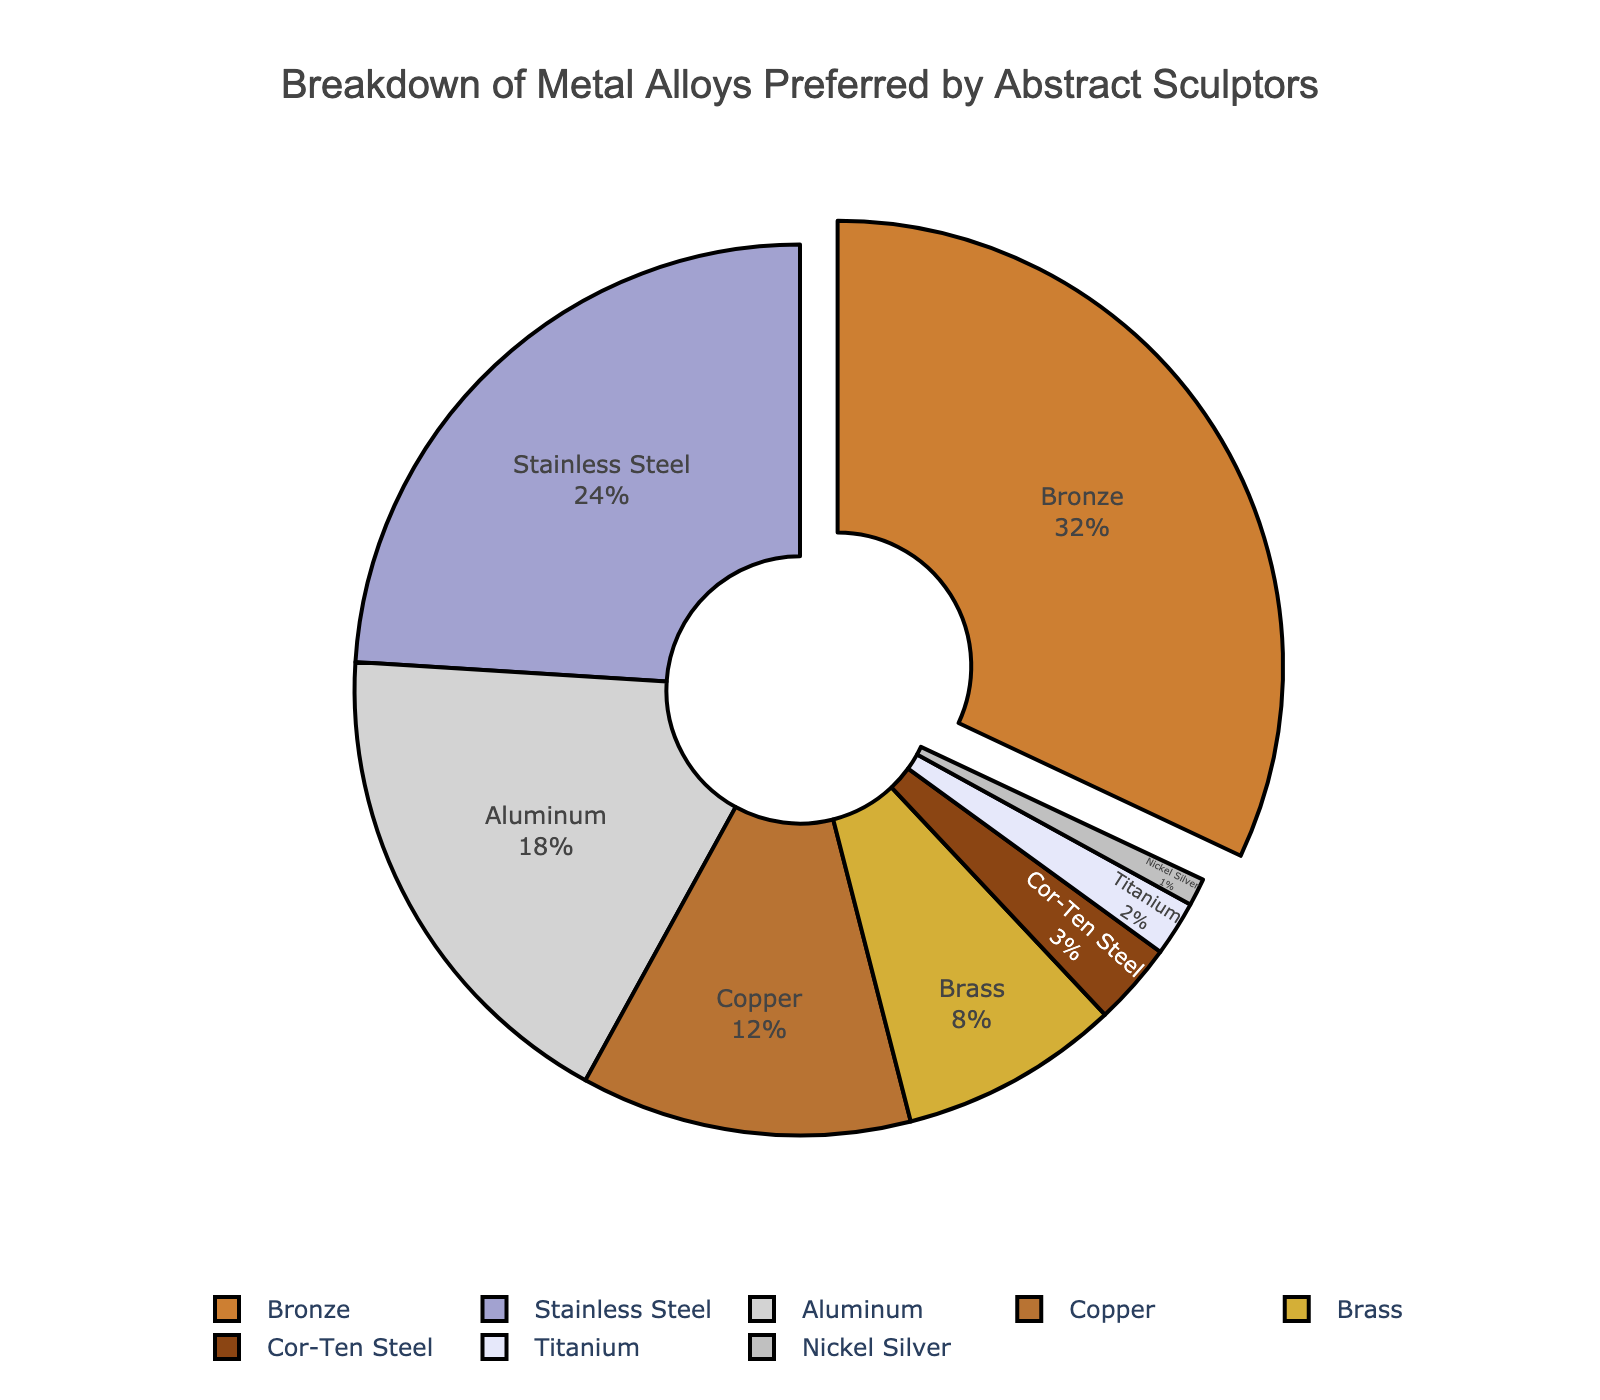What is the most preferred metal alloy by abstract sculptors? The most preferred metal alloy is indicated by the largest slice in the pie chart. The chart highlights this slice by pulling it out slightly. The metal alloy that is pulled out and has the largest slice is Bronze.
Answer: Bronze Which metal alloy has the second-highest preference among abstract sculptors? The second-largest slice in the pie chart will indicate the metal alloy with the second-highest preference. This slice corresponds to Stainless Steel.
Answer: Stainless Steel What is the combined percentage for Aluminum and Copper? To find the combined percentage, add the percentages of Aluminum and Copper together. Aluminum has 18% and Copper has 12%, so their combined percentage is 18% + 12% = 30%.
Answer: 30% How much more preferred is Bronze compared to Brass? Subtract the percentage of Brass from the percentage of Bronze. Bronze has 32% and Brass has 8%, so the difference is 32% - 8% = 24%.
Answer: 24% List all the metal alloys that are less preferred than Aluminum. Locate the slice representing Aluminum at 18% and then identify all slices representing metal alloys with percentages lower than 18%. These metal alloys are Copper (12%), Brass (8%), Cor-Ten Steel (3%), Titanium (2%), and Nickel Silver (1%).
Answer: Copper, Brass, Cor-Ten Steel, Titanium, Nickel Silver Which metal alloy has the smallest preference among abstract sculptors? Identify the smallest slice in the pie chart, which corresponds to the metal alloy with the smallest percentage. This slice represents Nickel Silver with 1%.
Answer: Nickel Silver How much more preferred is Stainless Steel compared to Titanium and Nickel Silver combined? First, find the combined percentage of Titanium and Nickel Silver: 2% + 1% = 3%. Then, subtract this combined percentage from the percentage of Stainless Steel: 24% - 3% = 21%.
Answer: 21% What percentage of metal alloys in the chart is represented by metals with less than 5% preference? Add the percentages of all metal alloys with less than 5% preference. These are Cor-Ten Steel (3%), Titanium (2%), and Nickel Silver (1%). The total is 3% + 2% + 1% = 6%.
Answer: 6% Which metal alloy is represented by a brownish color in the pie chart? The pie chart uses colors that are visually distinct. The slice represented by a brownish color can be identified as Bronze.
Answer: Bronze 